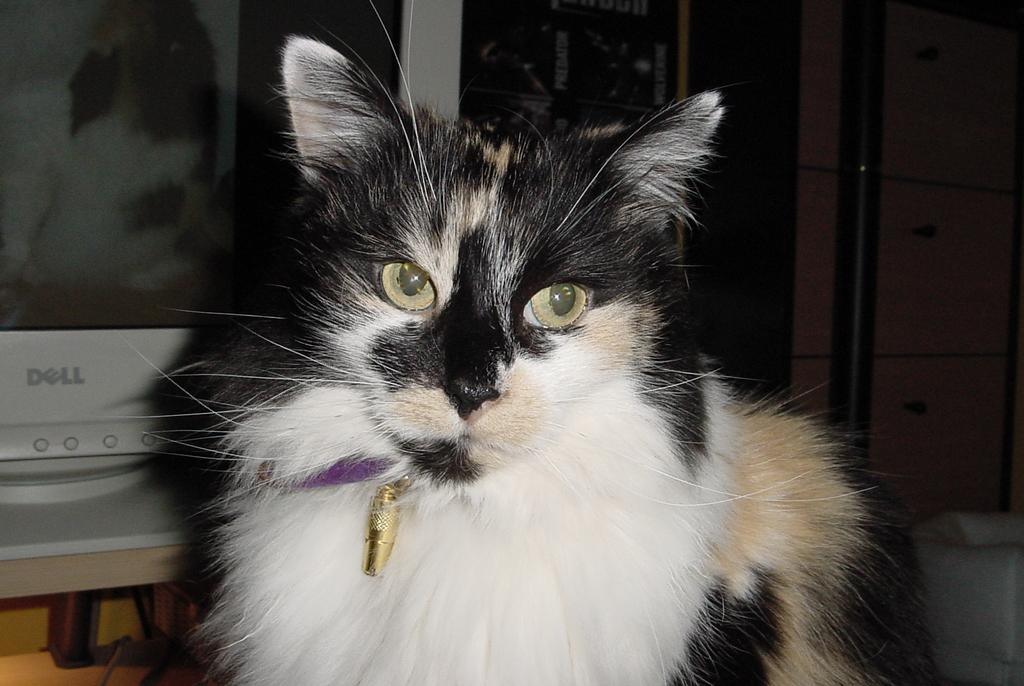<image>
Present a compact description of the photo's key features. A cat sits in front of a Dell monitor. 